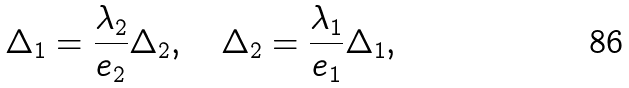<formula> <loc_0><loc_0><loc_500><loc_500>\Delta _ { 1 } = \frac { \lambda _ { 2 } } { e _ { 2 } } \Delta _ { 2 } , \quad \Delta _ { 2 } = \frac { \lambda _ { 1 } } { e _ { 1 } } \Delta _ { 1 } ,</formula> 